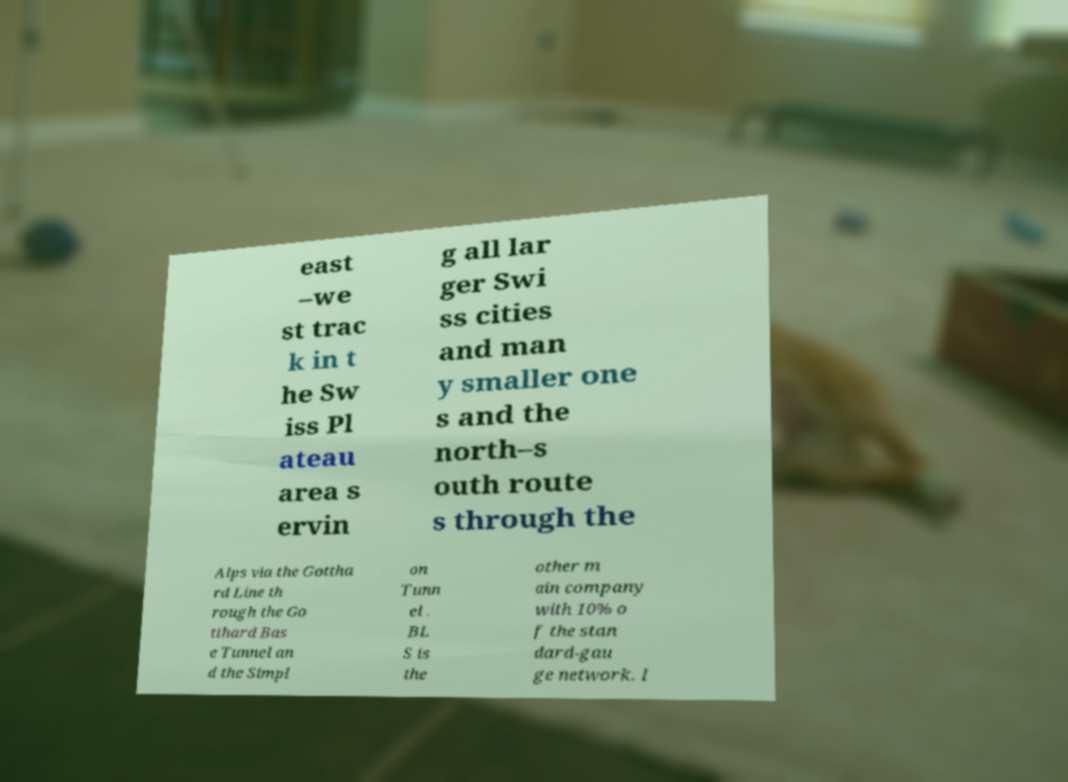Please identify and transcribe the text found in this image. east –we st trac k in t he Sw iss Pl ateau area s ervin g all lar ger Swi ss cities and man y smaller one s and the north–s outh route s through the Alps via the Gottha rd Line th rough the Go tthard Bas e Tunnel an d the Simpl on Tunn el . BL S is the other m ain company with 10% o f the stan dard-gau ge network. I 